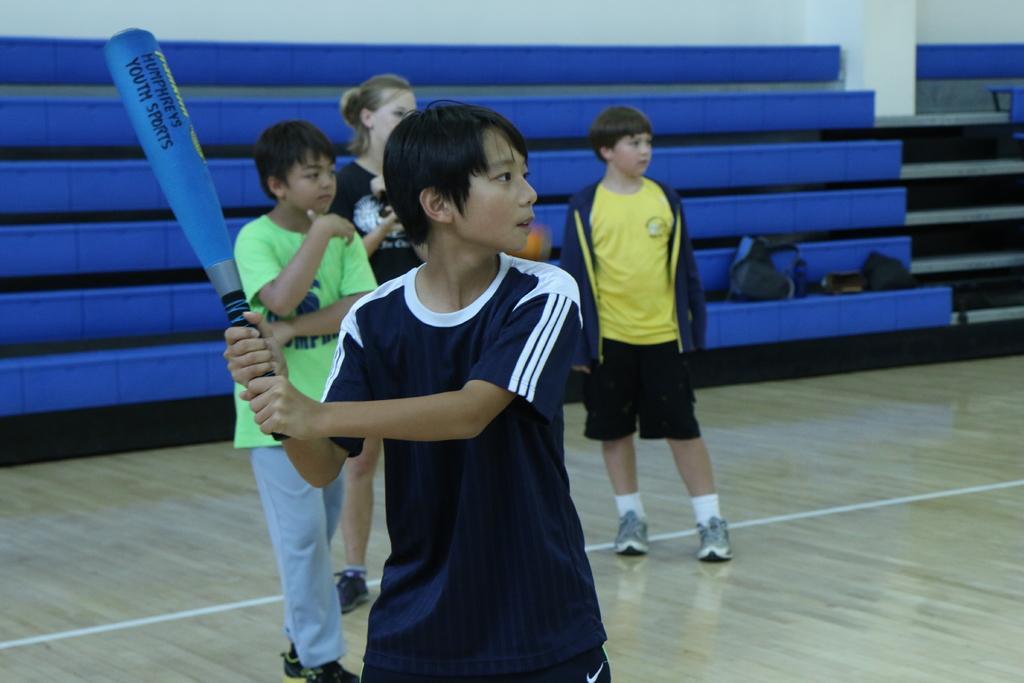Please provide a concise description of this image. In this image we can see a boy is standing and holding blue color bat in his hand and wearing dark blue color t-shirt. Background three children are standing. One is wearing yellow color t-shirt and the other one is wearing green color t-shirt and the third one is wearing blue color t-shirt. Behind them sitting area of the room is present. 